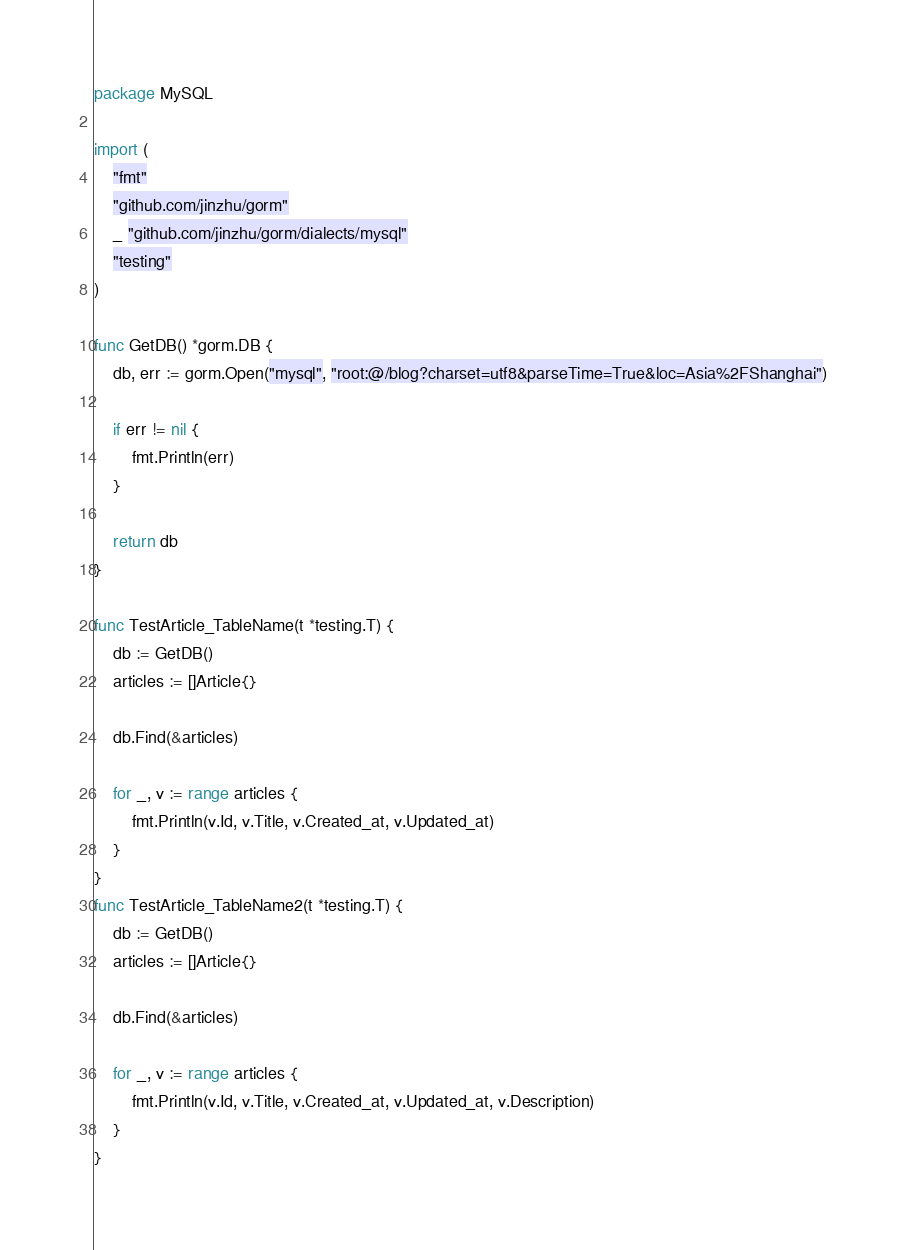Convert code to text. <code><loc_0><loc_0><loc_500><loc_500><_Go_>package MySQL

import (
	"fmt"
	"github.com/jinzhu/gorm"
	_ "github.com/jinzhu/gorm/dialects/mysql"
	"testing"
)

func GetDB() *gorm.DB {
	db, err := gorm.Open("mysql", "root:@/blog?charset=utf8&parseTime=True&loc=Asia%2FShanghai")

	if err != nil {
		fmt.Println(err)
	}

	return db
}

func TestArticle_TableName(t *testing.T) {
	db := GetDB()
	articles := []Article{}

	db.Find(&articles)

	for _, v := range articles {
		fmt.Println(v.Id, v.Title, v.Created_at, v.Updated_at)
	}
}
func TestArticle_TableName2(t *testing.T) {
	db := GetDB()
	articles := []Article{}

	db.Find(&articles)

	for _, v := range articles {
		fmt.Println(v.Id, v.Title, v.Created_at, v.Updated_at, v.Description)
	}
}
</code> 